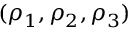Convert formula to latex. <formula><loc_0><loc_0><loc_500><loc_500>( \rho _ { 1 } , \rho _ { 2 } , \rho _ { 3 } )</formula> 